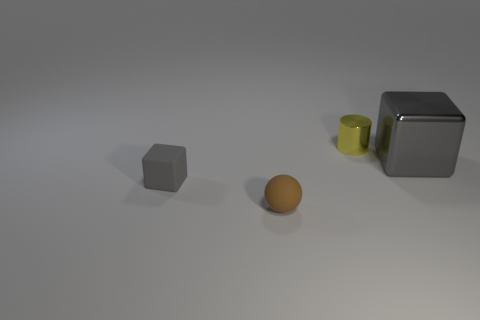Add 3 small gray rubber cubes. How many objects exist? 7 Subtract all cylinders. How many objects are left? 3 Add 3 tiny cylinders. How many tiny cylinders exist? 4 Subtract 0 brown blocks. How many objects are left? 4 Subtract all tiny yellow metal objects. Subtract all small blue things. How many objects are left? 3 Add 2 large objects. How many large objects are left? 3 